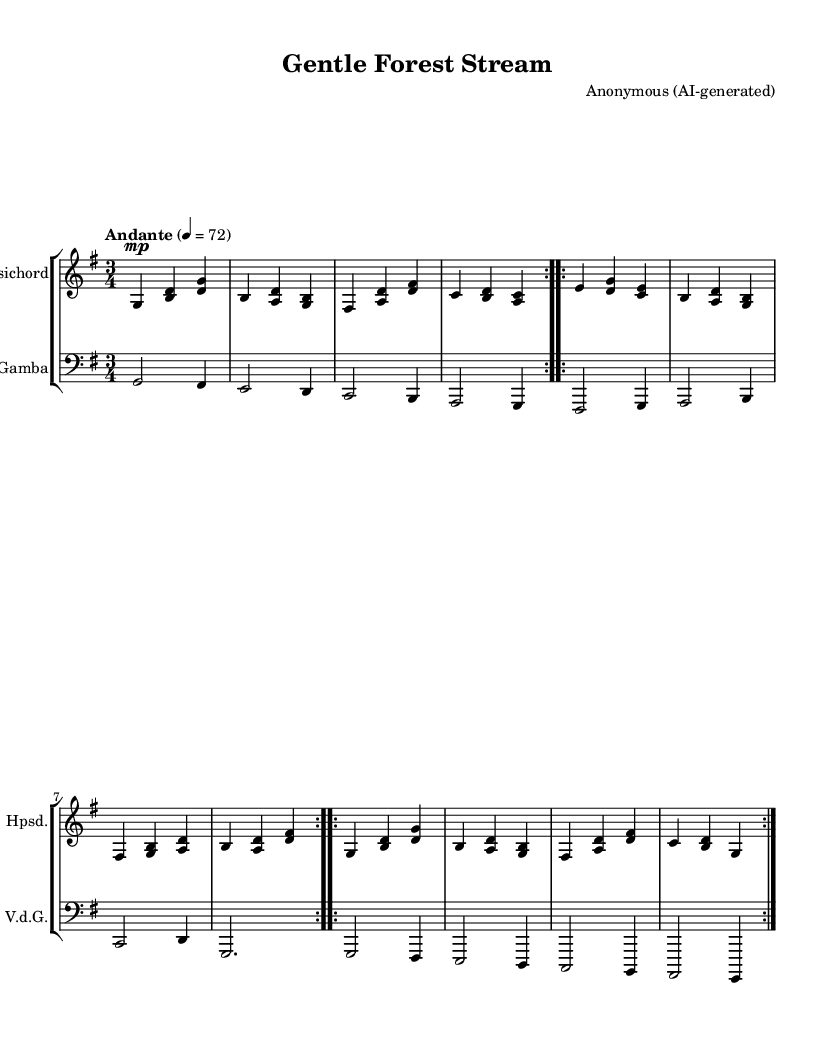What is the key signature of this piece? The key signature is G major, which has one sharp, indicated by the presence of F# on the lines or spaces of the staff.
Answer: G major What is the time signature of the music? The time signature is 3/4, which can be identified by the "3" on top and "4" on the bottom in the time signature notation.
Answer: 3/4 What is the tempo marking for this piece? The tempo marking is "Andante," which indicates a moderate pace. This is noted in the tempo instruction at the beginning of the score.
Answer: Andante How many sections are in the overall structure of the piece? The piece consists of three distinct sections: A, B, and A', as indicated by their repeated notations in the score.
Answer: Three What is the instrument combination in this score? The score features a harpsichord and a viola da gamba; this can be identified by the different staves labeled for each instrument.
Answer: Harpsichord and viola da gamba What is the dynamic marking at the beginning of the harpsichord part? The dynamic marking is "mp," which indicates "mezzo-piano" or moderately soft, located at the start of the harpsichord staff.
Answer: mp What does the repeat sign indicate about the sections of the music? The repeat signs indicate that sections A and B should be played twice, reflecting a common practice in Baroque music for thematic development.
Answer: Repeat twice 